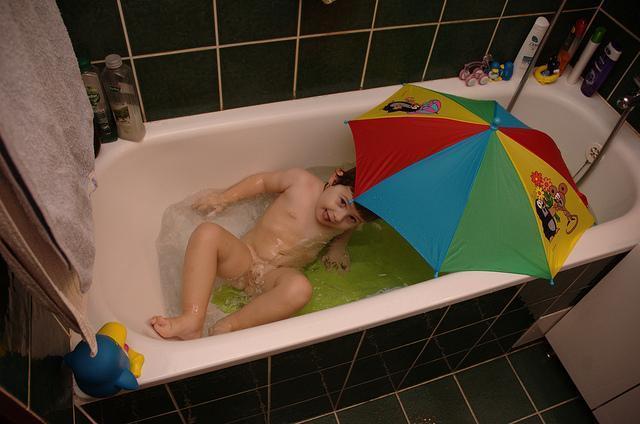How many colors are on the umbrella?
Give a very brief answer. 4. How many umbrellas are visible?
Give a very brief answer. 1. 